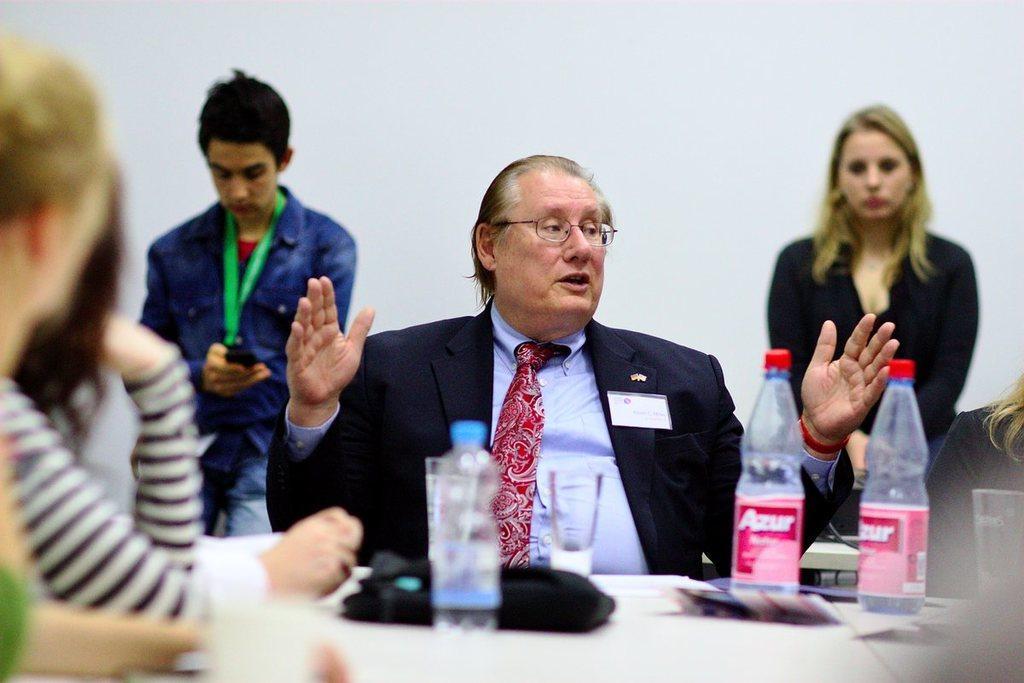In one or two sentences, can you explain what this image depicts? In this image i can see a man sitting and talking, there are two bottles , a glass, a paper on a table, at the back ground i can see a woman and a man standing, a man standing is holding a mobile at the background i can see a wall. 